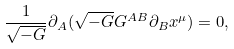<formula> <loc_0><loc_0><loc_500><loc_500>\frac { 1 } { \sqrt { - G } } \partial _ { A } ( \sqrt { - G } G ^ { A B } \partial _ { B } x ^ { \mu } ) = 0 ,</formula> 